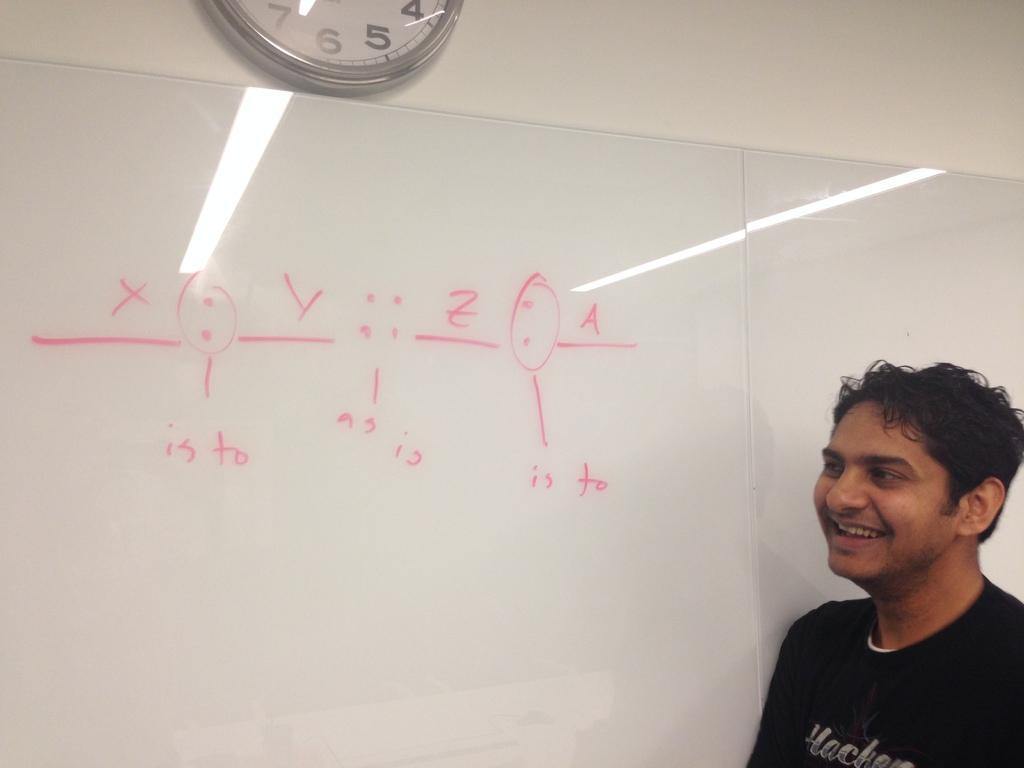Describe this image in one or two sentences. On the right side of this image there is a man smiling by looking at the left side. Here I can see some text on a white color board. At the top of the image there is a clock attached to the wall. 